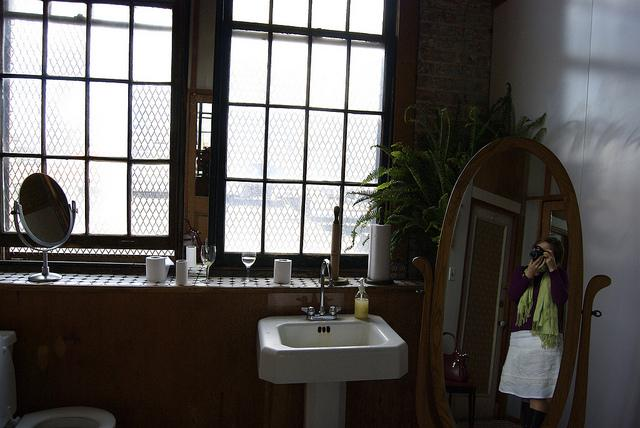Which feature of the camera poses harm to the person taking a photograph of a mirror?

Choices:
A) selfie stick
B) sounds
C) flash
D) dark mode flash 